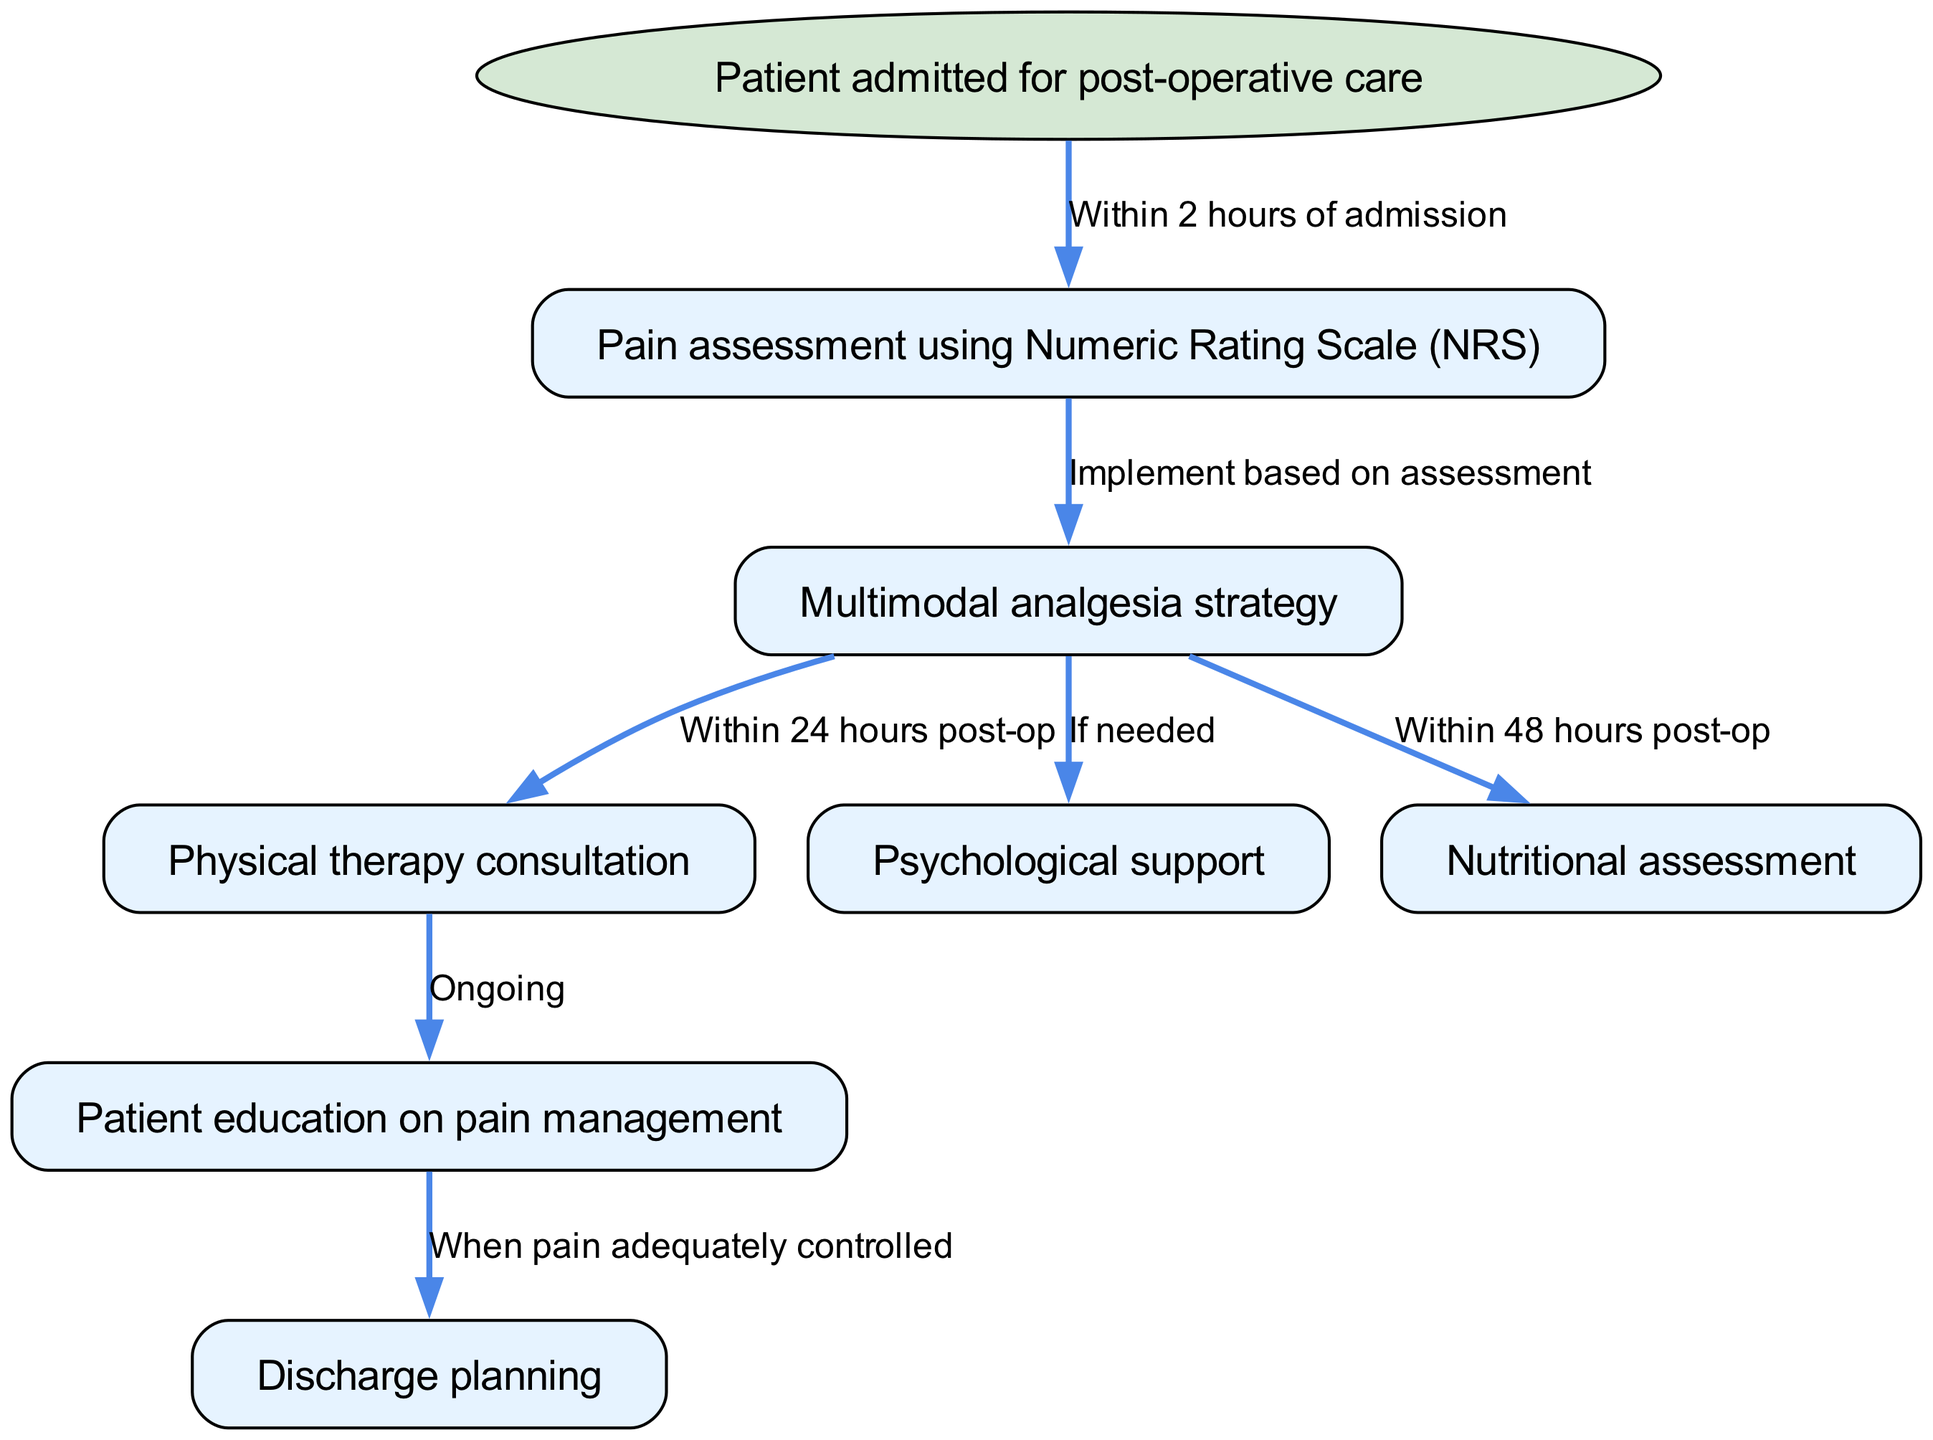What is the start node of the pathway? The start node is explicitly stated in the diagram as the first node that represents the beginning of the clinical pathway. It refers to the patient’s initial entry point into the process.
Answer: Patient admitted for post-operative care How many nodes are present in the diagram? By counting all the nodes listed in the diagram, we find a total of 7 distinct nodes that represent different steps in the clinical pathway for post-operative care.
Answer: 7 What is the relationship between "Pain assessment using Numeric Rating Scale (NRS)" and "Multimodal analgesia strategy"? The diagram indicates an edge from the pain assessment node to the multimodal analgesia strategy node, showing that the implementation of the analgesia strategy depends on the assessment outcome. The label specifies that it is implemented based on the assessment results.
Answer: Implement based on assessment When should the "Physical therapy consultation" occur after the "Multimodal analgesia strategy"? The label on the edge connecting these two nodes clearly states that the physical therapy consultation should occur within 24 hours post-operative, indicating a specific time frame for this step.
Answer: Within 24 hours post-op Is “Psychological support” always provided after the “Multimodal analgesia strategy”? The edge connecting these two nodes has a conditional statement, indicated by "If needed." This means that psychological support is not guaranteed; it depends on the patient’s specific situation and needs assessed during the pain management process.
Answer: If needed What triggers the "Discharge planning" node in the pathway? The pathway specifies that discharge planning occurs when pain is adequately controlled, indicating that the patient must meet specific pain management criteria before proceeding to discharge. This means that pain control is a prerequisite for this step.
Answer: When pain adequately controlled What two nodes are connected to "Multimodal analgesia strategy"? From analyzing the diagram, there are two distinct nodes that connect from the “Multimodal analgesia strategy” node: “Physical therapy consultation” and “Nutritional assessment.” Each has a designated time frame or condition specified in the edges.
Answer: Physical therapy consultation, Nutritional assessment Which assessment occurs within 48 hours post-operative? The edge connecting “Multimodal analgesia strategy” to “Nutritional assessment” explicitly states that this assessment should occur within a specified time frame, making it clear that this is the timeline for the nutritional evaluation of the patient.
Answer: Within 48 hours post-op 